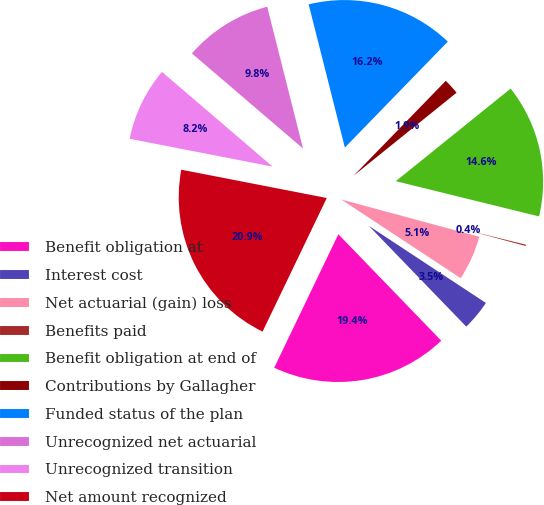<chart> <loc_0><loc_0><loc_500><loc_500><pie_chart><fcel>Benefit obligation at<fcel>Interest cost<fcel>Net actuarial (gain) loss<fcel>Benefits paid<fcel>Benefit obligation at end of<fcel>Contributions by Gallagher<fcel>Funded status of the plan<fcel>Unrecognized net actuarial<fcel>Unrecognized transition<fcel>Net amount recognized<nl><fcel>19.36%<fcel>3.5%<fcel>5.07%<fcel>0.36%<fcel>14.64%<fcel>1.93%<fcel>16.21%<fcel>9.79%<fcel>8.21%<fcel>20.93%<nl></chart> 